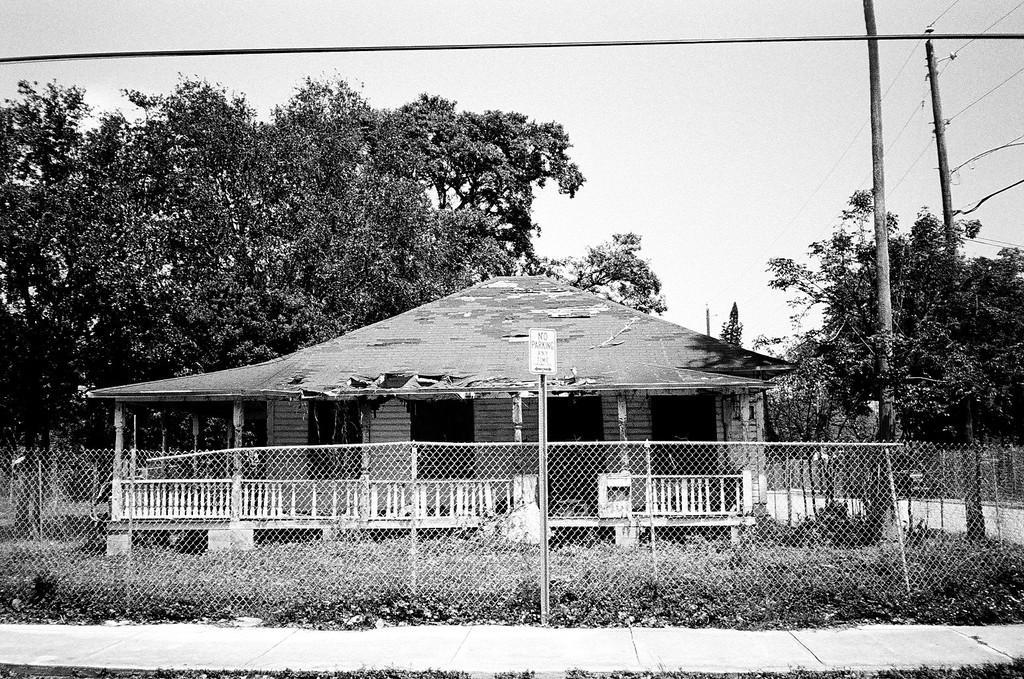Please provide a concise description of this image. In this black and white image, we can see a shelter house. There are some trees in the middle of the image. There are poles on the right side of the image. There is a fencing and sign board at the bottom of the image. There is a sky at the top of the image. 